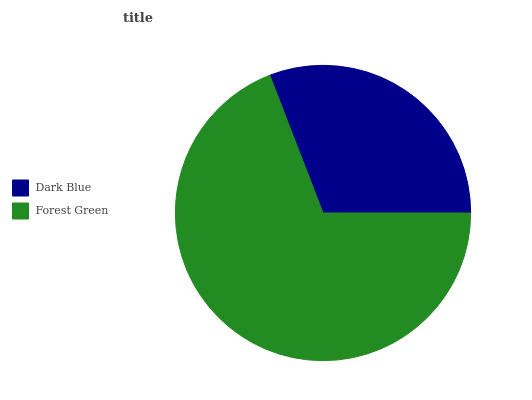Is Dark Blue the minimum?
Answer yes or no. Yes. Is Forest Green the maximum?
Answer yes or no. Yes. Is Forest Green the minimum?
Answer yes or no. No. Is Forest Green greater than Dark Blue?
Answer yes or no. Yes. Is Dark Blue less than Forest Green?
Answer yes or no. Yes. Is Dark Blue greater than Forest Green?
Answer yes or no. No. Is Forest Green less than Dark Blue?
Answer yes or no. No. Is Forest Green the high median?
Answer yes or no. Yes. Is Dark Blue the low median?
Answer yes or no. Yes. Is Dark Blue the high median?
Answer yes or no. No. Is Forest Green the low median?
Answer yes or no. No. 